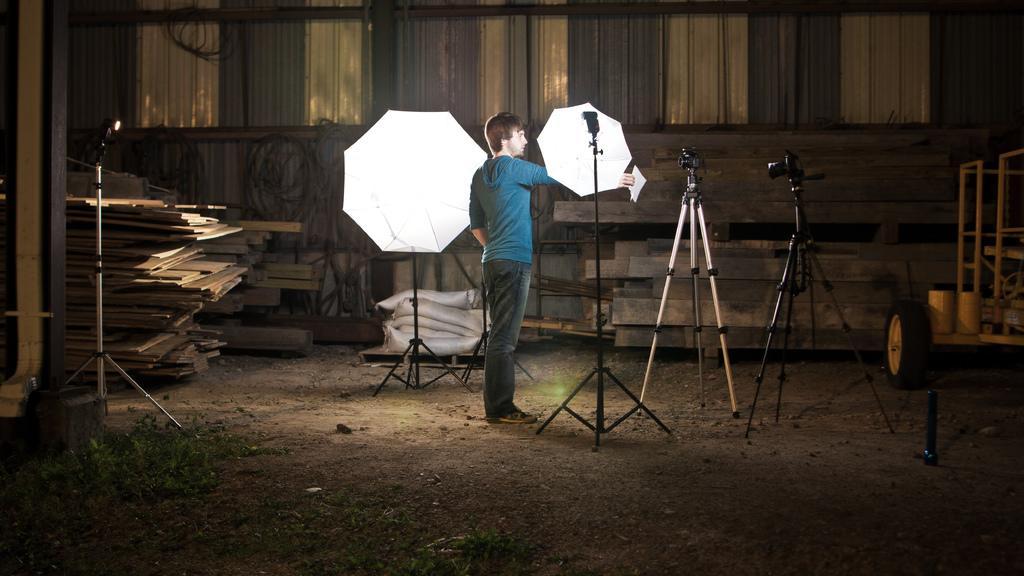Can you describe this image briefly? In the image we can see a man standing, wearing clothes. These are the cameras, stand, flash diffuser umbrella, wooden sheets, grass, sand and tires. 